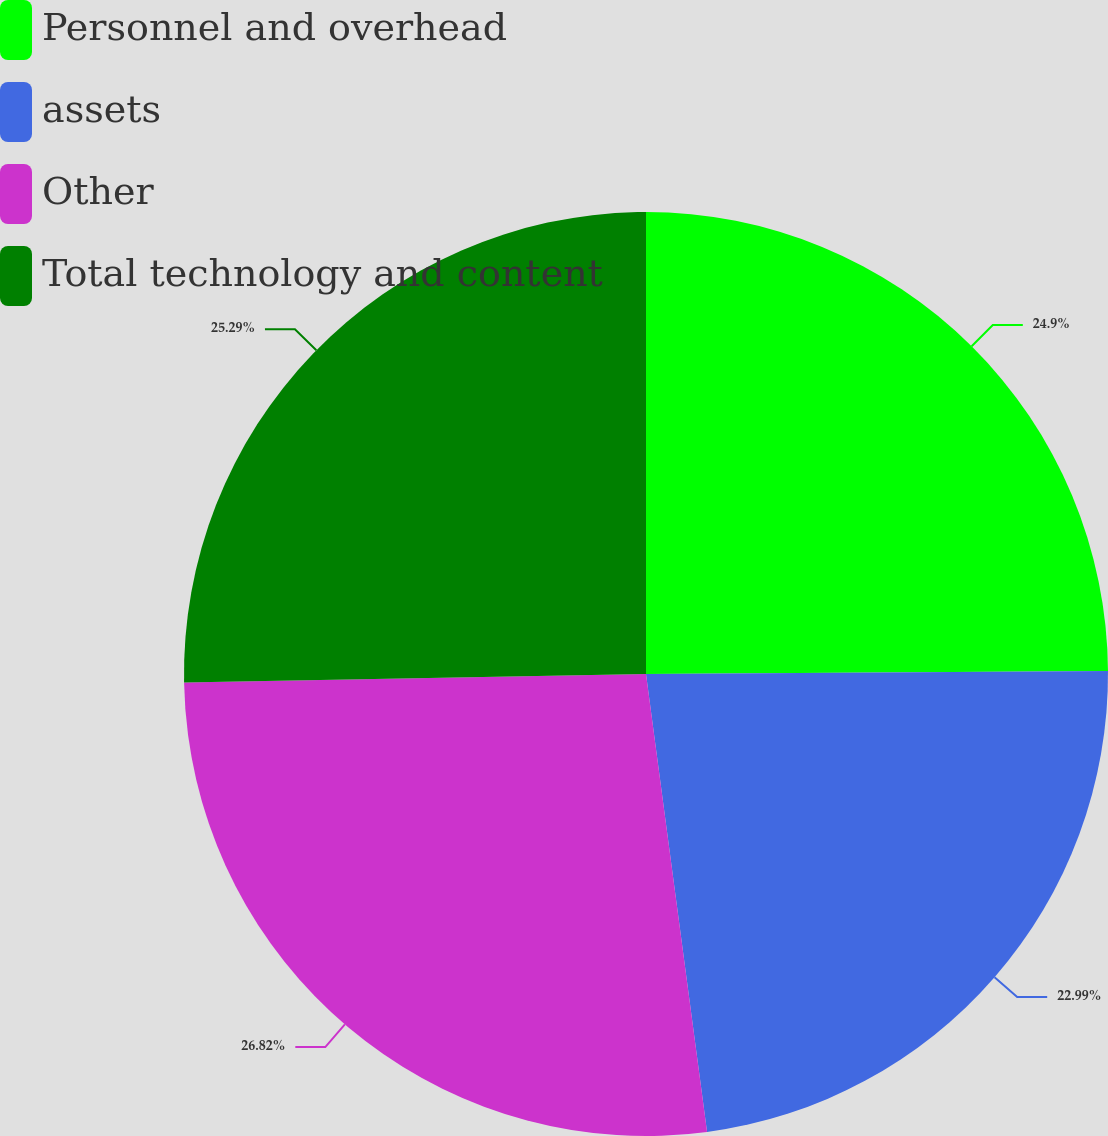Convert chart. <chart><loc_0><loc_0><loc_500><loc_500><pie_chart><fcel>Personnel and overhead<fcel>assets<fcel>Other<fcel>Total technology and content<nl><fcel>24.9%<fcel>22.99%<fcel>26.82%<fcel>25.29%<nl></chart> 